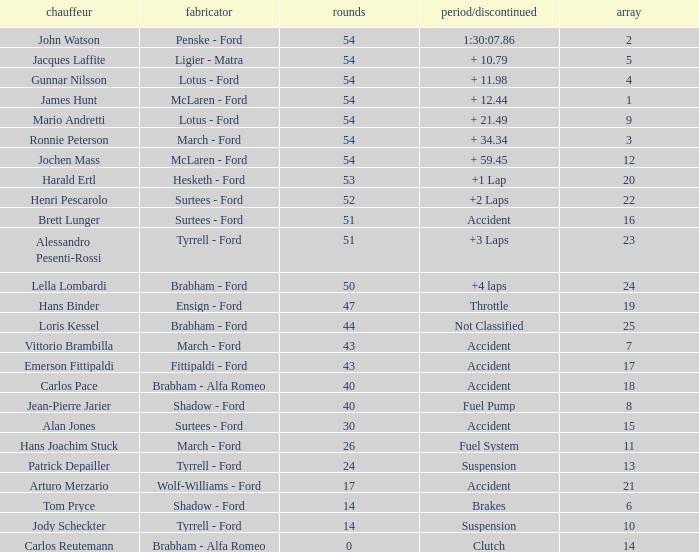How many laps did Emerson Fittipaldi do on a grid larger than 14, and when was the Time/Retired of accident? 1.0. 